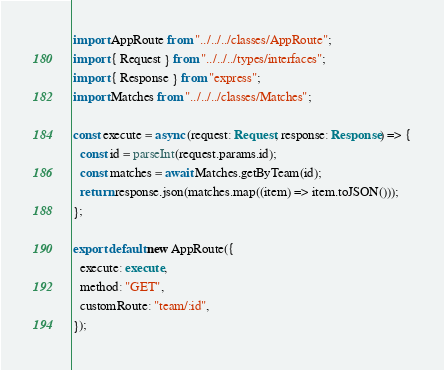Convert code to text. <code><loc_0><loc_0><loc_500><loc_500><_TypeScript_>import AppRoute from "../../../classes/AppRoute";
import { Request } from "../../../types/interfaces";
import { Response } from "express";
import Matches from "../../../classes/Matches";

const execute = async (request: Request, response: Response) => {
  const id = parseInt(request.params.id);
  const matches = await Matches.getByTeam(id);
  return response.json(matches.map((item) => item.toJSON()));
};

export default new AppRoute({
  execute: execute,
  method: "GET",
  customRoute: "team/:id",
});
</code> 